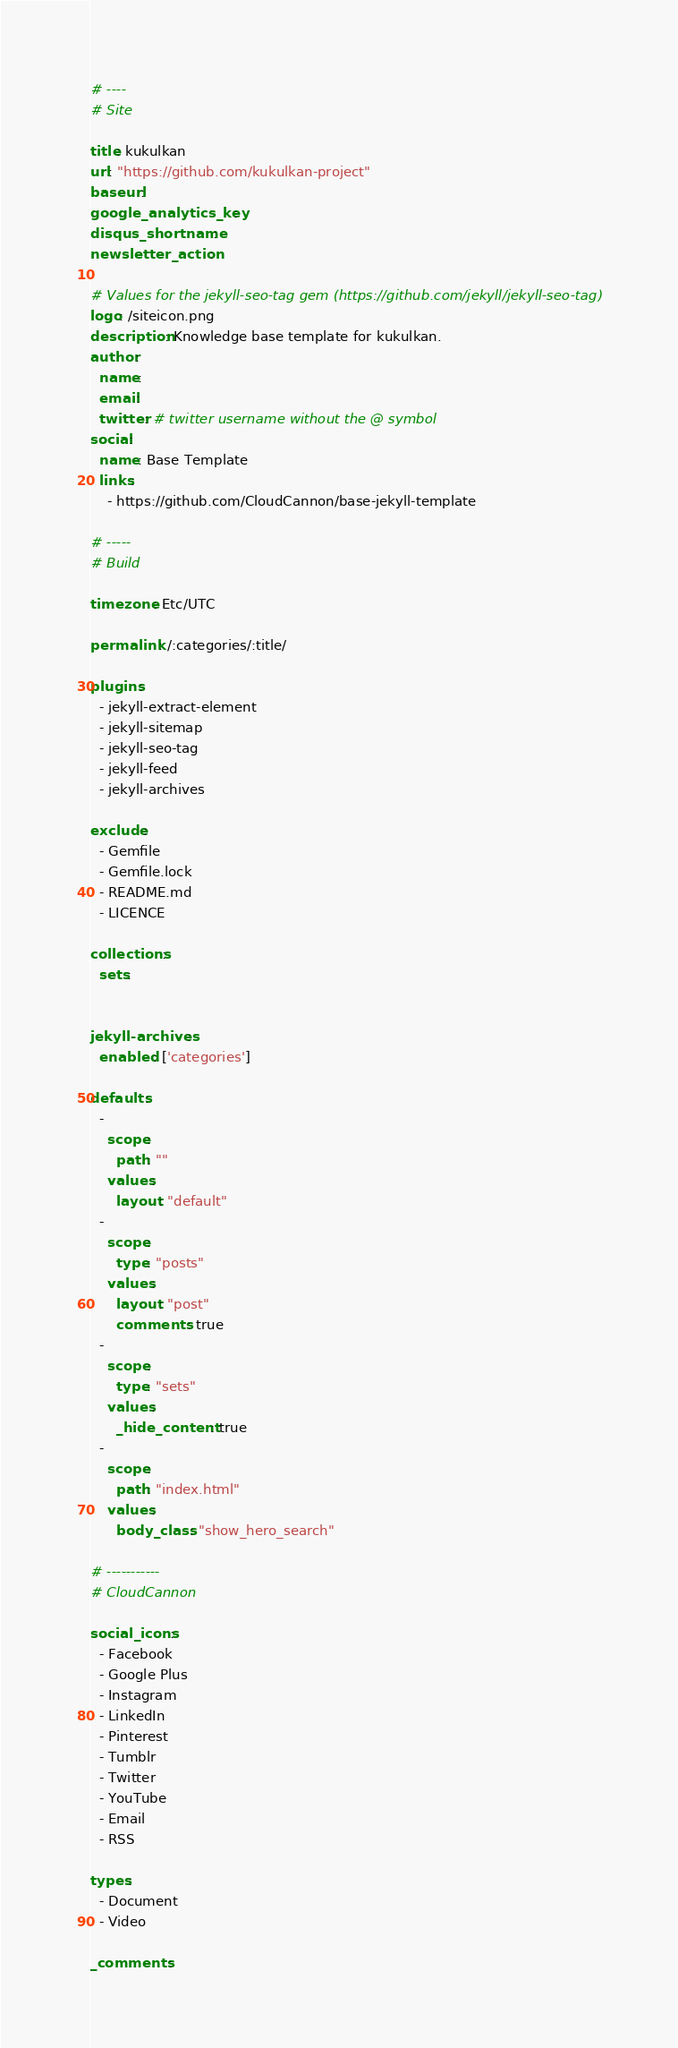Convert code to text. <code><loc_0><loc_0><loc_500><loc_500><_YAML_># ----
# Site

title: kukulkan
url: "https://github.com/kukulkan-project"
baseurl:
google_analytics_key:
disqus_shortname:
newsletter_action:

# Values for the jekyll-seo-tag gem (https://github.com/jekyll/jekyll-seo-tag)
logo: /siteicon.png
description: Knowledge base template for kukulkan.
author:
  name:
  email:
  twitter: # twitter username without the @ symbol
social:
  name: Base Template
  links:
    - https://github.com/CloudCannon/base-jekyll-template

# -----
# Build

timezone: Etc/UTC

permalink: /:categories/:title/

plugins:
  - jekyll-extract-element
  - jekyll-sitemap
  - jekyll-seo-tag
  - jekyll-feed
  - jekyll-archives

exclude:
  - Gemfile
  - Gemfile.lock
  - README.md
  - LICENCE

collections:
  sets:


jekyll-archives:
  enabled: ['categories']

defaults:
  -
    scope:
      path: ""
    values:
      layout: "default"
  -
    scope:
      type: "posts"
    values:
      layout: "post"
      comments: true
  -
    scope:
      type: "sets"
    values:
      _hide_content: true
  -
    scope:
      path: "index.html"
    values:
      body_class: "show_hero_search"

# -----------
# CloudCannon

social_icons:
  - Facebook
  - Google Plus
  - Instagram
  - LinkedIn
  - Pinterest
  - Tumblr
  - Twitter
  - YouTube
  - Email
  - RSS

types:
  - Document
  - Video

_comments:
</code> 